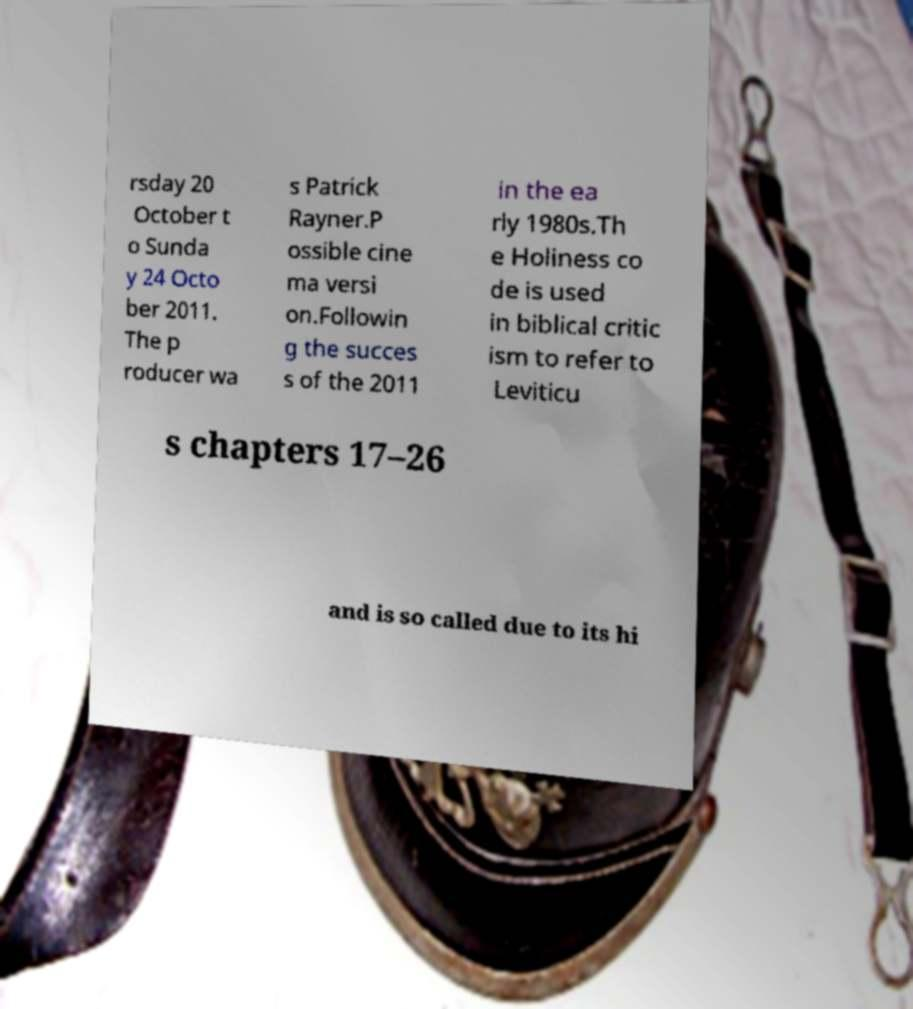For documentation purposes, I need the text within this image transcribed. Could you provide that? rsday 20 October t o Sunda y 24 Octo ber 2011. The p roducer wa s Patrick Rayner.P ossible cine ma versi on.Followin g the succes s of the 2011 in the ea rly 1980s.Th e Holiness co de is used in biblical critic ism to refer to Leviticu s chapters 17–26 and is so called due to its hi 